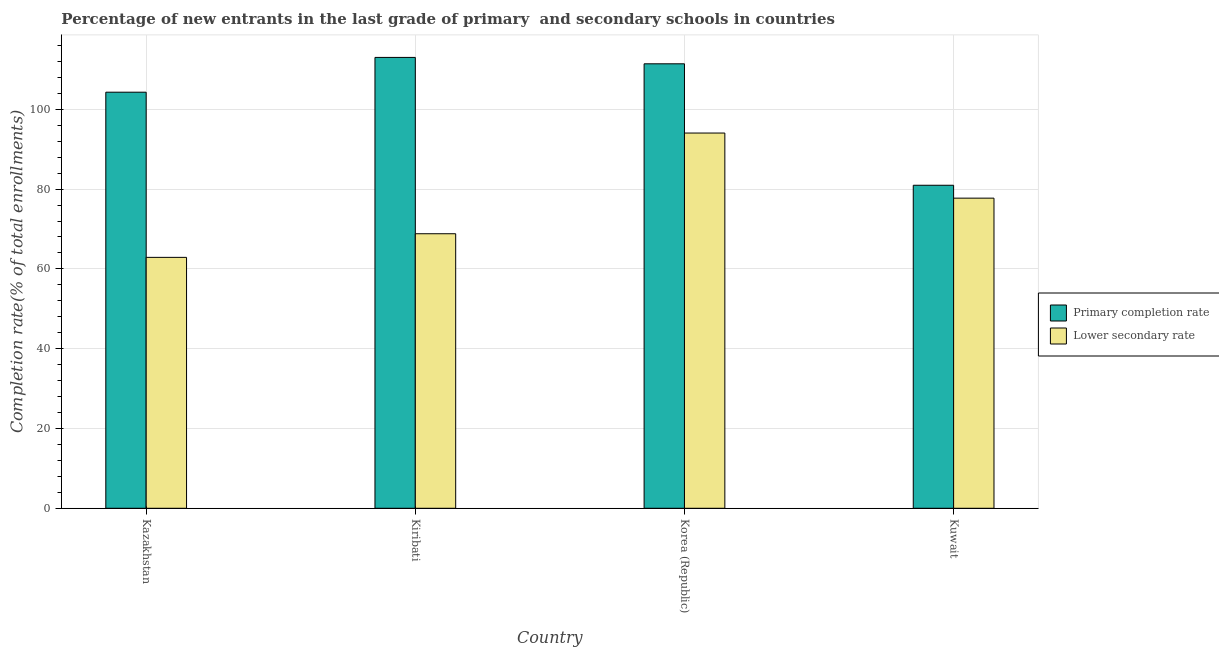How many groups of bars are there?
Your answer should be compact. 4. Are the number of bars per tick equal to the number of legend labels?
Offer a terse response. Yes. How many bars are there on the 3rd tick from the left?
Your answer should be compact. 2. What is the label of the 4th group of bars from the left?
Offer a very short reply. Kuwait. What is the completion rate in secondary schools in Korea (Republic)?
Make the answer very short. 94.05. Across all countries, what is the maximum completion rate in secondary schools?
Your answer should be very brief. 94.05. Across all countries, what is the minimum completion rate in primary schools?
Offer a very short reply. 80.96. In which country was the completion rate in primary schools maximum?
Give a very brief answer. Kiribati. In which country was the completion rate in primary schools minimum?
Give a very brief answer. Kuwait. What is the total completion rate in primary schools in the graph?
Your response must be concise. 409.66. What is the difference between the completion rate in primary schools in Korea (Republic) and that in Kuwait?
Give a very brief answer. 30.44. What is the difference between the completion rate in secondary schools in Kazakhstan and the completion rate in primary schools in Korea (Republic)?
Your response must be concise. -48.52. What is the average completion rate in primary schools per country?
Make the answer very short. 102.42. What is the difference between the completion rate in primary schools and completion rate in secondary schools in Kazakhstan?
Provide a succinct answer. 41.4. In how many countries, is the completion rate in primary schools greater than 100 %?
Offer a very short reply. 3. What is the ratio of the completion rate in primary schools in Korea (Republic) to that in Kuwait?
Ensure brevity in your answer.  1.38. Is the completion rate in secondary schools in Korea (Republic) less than that in Kuwait?
Offer a terse response. No. What is the difference between the highest and the second highest completion rate in primary schools?
Provide a succinct answer. 1.6. What is the difference between the highest and the lowest completion rate in secondary schools?
Make the answer very short. 31.16. In how many countries, is the completion rate in secondary schools greater than the average completion rate in secondary schools taken over all countries?
Offer a very short reply. 2. Is the sum of the completion rate in secondary schools in Korea (Republic) and Kuwait greater than the maximum completion rate in primary schools across all countries?
Ensure brevity in your answer.  Yes. What does the 2nd bar from the left in Kuwait represents?
Ensure brevity in your answer.  Lower secondary rate. What does the 2nd bar from the right in Korea (Republic) represents?
Ensure brevity in your answer.  Primary completion rate. How many bars are there?
Provide a short and direct response. 8. Are all the bars in the graph horizontal?
Give a very brief answer. No. What is the difference between two consecutive major ticks on the Y-axis?
Offer a very short reply. 20. Does the graph contain any zero values?
Provide a succinct answer. No. Does the graph contain grids?
Your answer should be compact. Yes. Where does the legend appear in the graph?
Offer a very short reply. Center right. How many legend labels are there?
Give a very brief answer. 2. How are the legend labels stacked?
Offer a very short reply. Vertical. What is the title of the graph?
Provide a short and direct response. Percentage of new entrants in the last grade of primary  and secondary schools in countries. What is the label or title of the X-axis?
Make the answer very short. Country. What is the label or title of the Y-axis?
Your answer should be compact. Completion rate(% of total enrollments). What is the Completion rate(% of total enrollments) of Primary completion rate in Kazakhstan?
Give a very brief answer. 104.29. What is the Completion rate(% of total enrollments) in Lower secondary rate in Kazakhstan?
Your answer should be very brief. 62.89. What is the Completion rate(% of total enrollments) in Primary completion rate in Kiribati?
Offer a terse response. 113. What is the Completion rate(% of total enrollments) in Lower secondary rate in Kiribati?
Offer a terse response. 68.81. What is the Completion rate(% of total enrollments) of Primary completion rate in Korea (Republic)?
Ensure brevity in your answer.  111.4. What is the Completion rate(% of total enrollments) in Lower secondary rate in Korea (Republic)?
Provide a succinct answer. 94.05. What is the Completion rate(% of total enrollments) in Primary completion rate in Kuwait?
Your answer should be very brief. 80.96. What is the Completion rate(% of total enrollments) in Lower secondary rate in Kuwait?
Offer a very short reply. 77.73. Across all countries, what is the maximum Completion rate(% of total enrollments) in Primary completion rate?
Your answer should be very brief. 113. Across all countries, what is the maximum Completion rate(% of total enrollments) in Lower secondary rate?
Keep it short and to the point. 94.05. Across all countries, what is the minimum Completion rate(% of total enrollments) in Primary completion rate?
Your answer should be compact. 80.96. Across all countries, what is the minimum Completion rate(% of total enrollments) in Lower secondary rate?
Your answer should be compact. 62.89. What is the total Completion rate(% of total enrollments) of Primary completion rate in the graph?
Keep it short and to the point. 409.66. What is the total Completion rate(% of total enrollments) of Lower secondary rate in the graph?
Keep it short and to the point. 303.48. What is the difference between the Completion rate(% of total enrollments) in Primary completion rate in Kazakhstan and that in Kiribati?
Offer a terse response. -8.71. What is the difference between the Completion rate(% of total enrollments) of Lower secondary rate in Kazakhstan and that in Kiribati?
Give a very brief answer. -5.92. What is the difference between the Completion rate(% of total enrollments) in Primary completion rate in Kazakhstan and that in Korea (Republic)?
Keep it short and to the point. -7.11. What is the difference between the Completion rate(% of total enrollments) of Lower secondary rate in Kazakhstan and that in Korea (Republic)?
Give a very brief answer. -31.16. What is the difference between the Completion rate(% of total enrollments) of Primary completion rate in Kazakhstan and that in Kuwait?
Your response must be concise. 23.33. What is the difference between the Completion rate(% of total enrollments) of Lower secondary rate in Kazakhstan and that in Kuwait?
Ensure brevity in your answer.  -14.84. What is the difference between the Completion rate(% of total enrollments) of Primary completion rate in Kiribati and that in Korea (Republic)?
Provide a succinct answer. 1.6. What is the difference between the Completion rate(% of total enrollments) of Lower secondary rate in Kiribati and that in Korea (Republic)?
Provide a succinct answer. -25.24. What is the difference between the Completion rate(% of total enrollments) of Primary completion rate in Kiribati and that in Kuwait?
Make the answer very short. 32.04. What is the difference between the Completion rate(% of total enrollments) of Lower secondary rate in Kiribati and that in Kuwait?
Ensure brevity in your answer.  -8.92. What is the difference between the Completion rate(% of total enrollments) of Primary completion rate in Korea (Republic) and that in Kuwait?
Your response must be concise. 30.44. What is the difference between the Completion rate(% of total enrollments) of Lower secondary rate in Korea (Republic) and that in Kuwait?
Your answer should be compact. 16.32. What is the difference between the Completion rate(% of total enrollments) in Primary completion rate in Kazakhstan and the Completion rate(% of total enrollments) in Lower secondary rate in Kiribati?
Your answer should be compact. 35.48. What is the difference between the Completion rate(% of total enrollments) of Primary completion rate in Kazakhstan and the Completion rate(% of total enrollments) of Lower secondary rate in Korea (Republic)?
Provide a short and direct response. 10.24. What is the difference between the Completion rate(% of total enrollments) in Primary completion rate in Kazakhstan and the Completion rate(% of total enrollments) in Lower secondary rate in Kuwait?
Offer a very short reply. 26.56. What is the difference between the Completion rate(% of total enrollments) of Primary completion rate in Kiribati and the Completion rate(% of total enrollments) of Lower secondary rate in Korea (Republic)?
Your answer should be compact. 18.95. What is the difference between the Completion rate(% of total enrollments) of Primary completion rate in Kiribati and the Completion rate(% of total enrollments) of Lower secondary rate in Kuwait?
Your answer should be compact. 35.28. What is the difference between the Completion rate(% of total enrollments) of Primary completion rate in Korea (Republic) and the Completion rate(% of total enrollments) of Lower secondary rate in Kuwait?
Provide a short and direct response. 33.67. What is the average Completion rate(% of total enrollments) in Primary completion rate per country?
Your response must be concise. 102.42. What is the average Completion rate(% of total enrollments) in Lower secondary rate per country?
Make the answer very short. 75.87. What is the difference between the Completion rate(% of total enrollments) in Primary completion rate and Completion rate(% of total enrollments) in Lower secondary rate in Kazakhstan?
Offer a terse response. 41.4. What is the difference between the Completion rate(% of total enrollments) of Primary completion rate and Completion rate(% of total enrollments) of Lower secondary rate in Kiribati?
Provide a succinct answer. 44.19. What is the difference between the Completion rate(% of total enrollments) in Primary completion rate and Completion rate(% of total enrollments) in Lower secondary rate in Korea (Republic)?
Make the answer very short. 17.35. What is the difference between the Completion rate(% of total enrollments) of Primary completion rate and Completion rate(% of total enrollments) of Lower secondary rate in Kuwait?
Make the answer very short. 3.23. What is the ratio of the Completion rate(% of total enrollments) of Primary completion rate in Kazakhstan to that in Kiribati?
Keep it short and to the point. 0.92. What is the ratio of the Completion rate(% of total enrollments) of Lower secondary rate in Kazakhstan to that in Kiribati?
Ensure brevity in your answer.  0.91. What is the ratio of the Completion rate(% of total enrollments) of Primary completion rate in Kazakhstan to that in Korea (Republic)?
Provide a succinct answer. 0.94. What is the ratio of the Completion rate(% of total enrollments) of Lower secondary rate in Kazakhstan to that in Korea (Republic)?
Give a very brief answer. 0.67. What is the ratio of the Completion rate(% of total enrollments) of Primary completion rate in Kazakhstan to that in Kuwait?
Ensure brevity in your answer.  1.29. What is the ratio of the Completion rate(% of total enrollments) in Lower secondary rate in Kazakhstan to that in Kuwait?
Ensure brevity in your answer.  0.81. What is the ratio of the Completion rate(% of total enrollments) of Primary completion rate in Kiribati to that in Korea (Republic)?
Offer a very short reply. 1.01. What is the ratio of the Completion rate(% of total enrollments) of Lower secondary rate in Kiribati to that in Korea (Republic)?
Make the answer very short. 0.73. What is the ratio of the Completion rate(% of total enrollments) in Primary completion rate in Kiribati to that in Kuwait?
Ensure brevity in your answer.  1.4. What is the ratio of the Completion rate(% of total enrollments) of Lower secondary rate in Kiribati to that in Kuwait?
Offer a terse response. 0.89. What is the ratio of the Completion rate(% of total enrollments) of Primary completion rate in Korea (Republic) to that in Kuwait?
Provide a short and direct response. 1.38. What is the ratio of the Completion rate(% of total enrollments) of Lower secondary rate in Korea (Republic) to that in Kuwait?
Make the answer very short. 1.21. What is the difference between the highest and the second highest Completion rate(% of total enrollments) in Primary completion rate?
Offer a very short reply. 1.6. What is the difference between the highest and the second highest Completion rate(% of total enrollments) in Lower secondary rate?
Ensure brevity in your answer.  16.32. What is the difference between the highest and the lowest Completion rate(% of total enrollments) of Primary completion rate?
Ensure brevity in your answer.  32.04. What is the difference between the highest and the lowest Completion rate(% of total enrollments) of Lower secondary rate?
Provide a succinct answer. 31.16. 